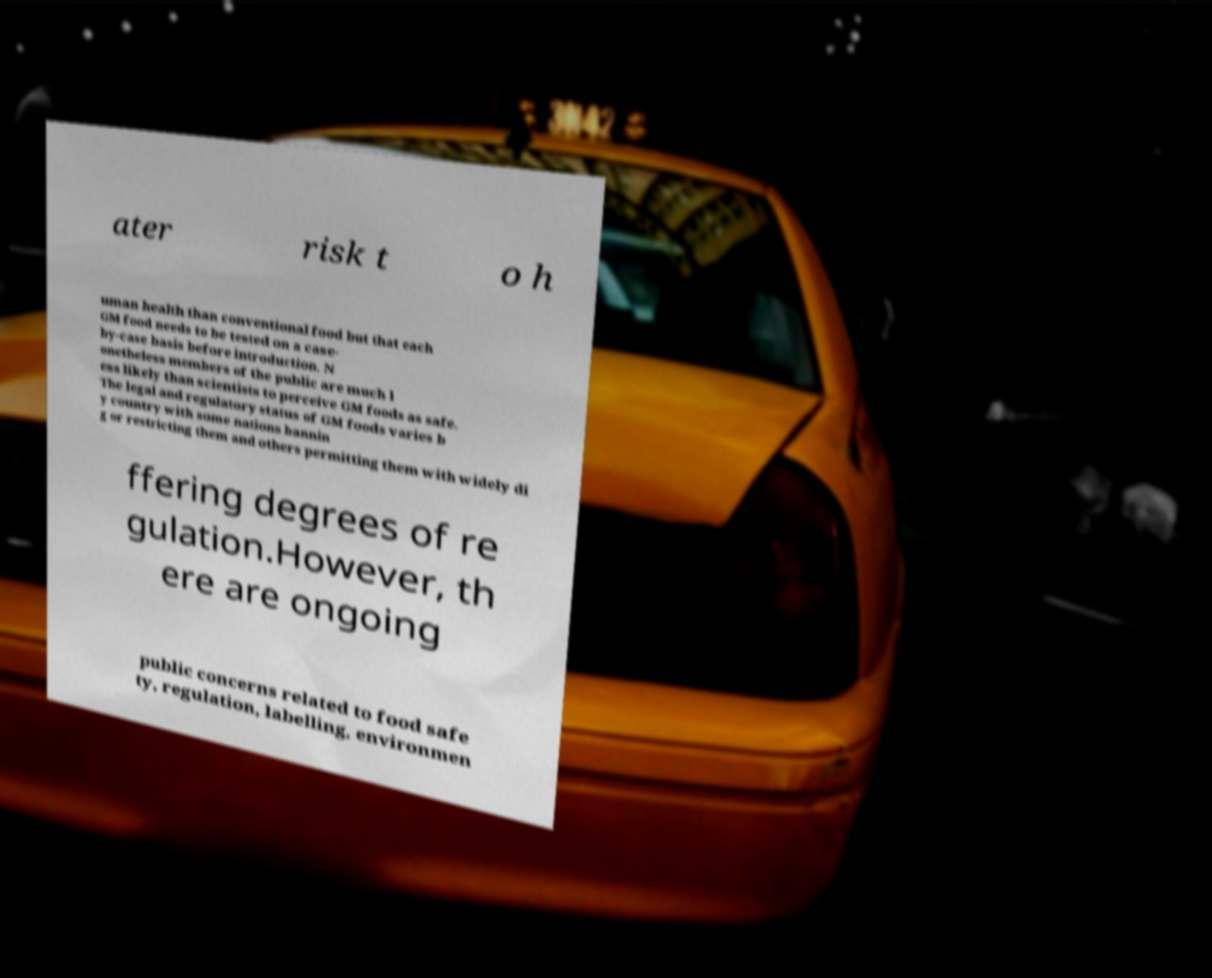Please identify and transcribe the text found in this image. ater risk t o h uman health than conventional food but that each GM food needs to be tested on a case- by-case basis before introduction. N onetheless members of the public are much l ess likely than scientists to perceive GM foods as safe. The legal and regulatory status of GM foods varies b y country with some nations bannin g or restricting them and others permitting them with widely di ffering degrees of re gulation.However, th ere are ongoing public concerns related to food safe ty, regulation, labelling, environmen 